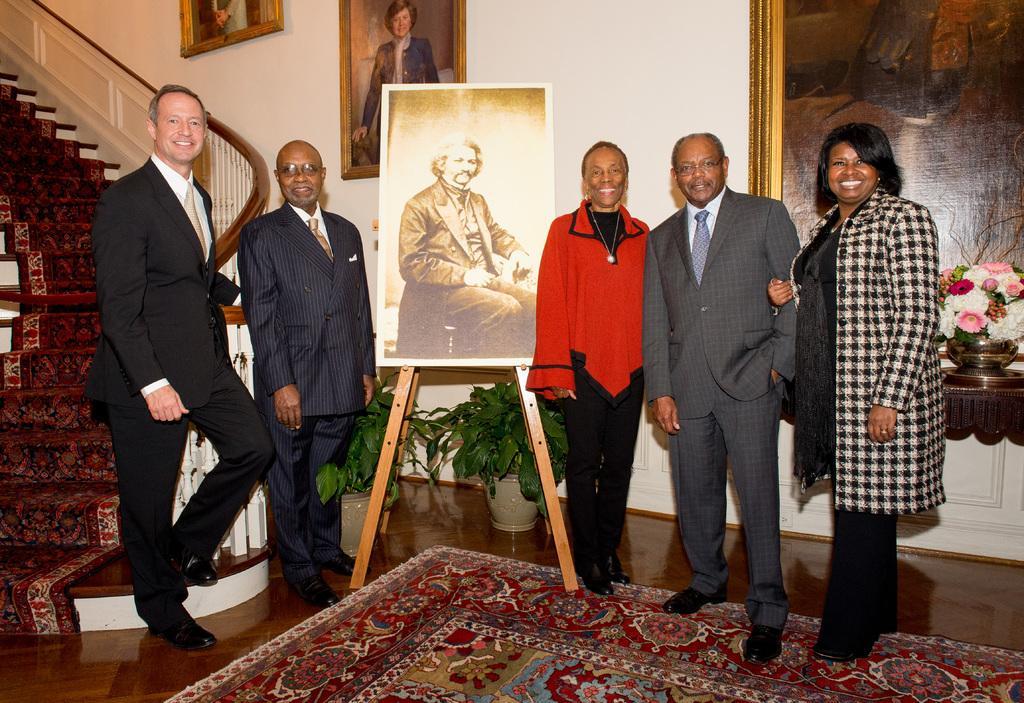In one or two sentences, can you explain what this image depicts? In this image we can see some people standing on the floor. We can also see a photo frame to a stand and plants in a pot. On the backside we can see some stairs, photo frames hanged to a wall and a flower pot. 